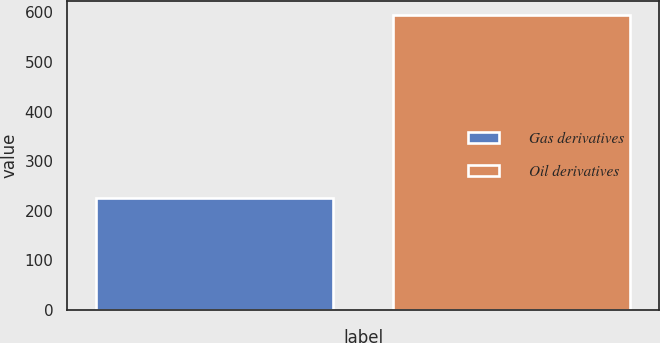Convert chart. <chart><loc_0><loc_0><loc_500><loc_500><bar_chart><fcel>Gas derivatives<fcel>Oil derivatives<nl><fcel>225<fcel>594<nl></chart> 